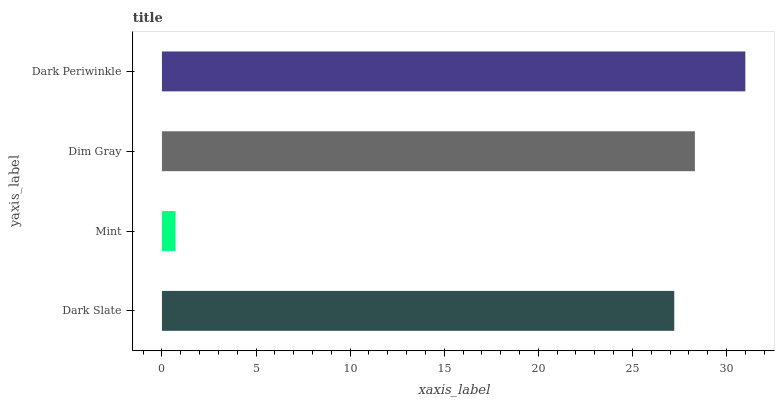Is Mint the minimum?
Answer yes or no. Yes. Is Dark Periwinkle the maximum?
Answer yes or no. Yes. Is Dim Gray the minimum?
Answer yes or no. No. Is Dim Gray the maximum?
Answer yes or no. No. Is Dim Gray greater than Mint?
Answer yes or no. Yes. Is Mint less than Dim Gray?
Answer yes or no. Yes. Is Mint greater than Dim Gray?
Answer yes or no. No. Is Dim Gray less than Mint?
Answer yes or no. No. Is Dim Gray the high median?
Answer yes or no. Yes. Is Dark Slate the low median?
Answer yes or no. Yes. Is Dark Slate the high median?
Answer yes or no. No. Is Mint the low median?
Answer yes or no. No. 